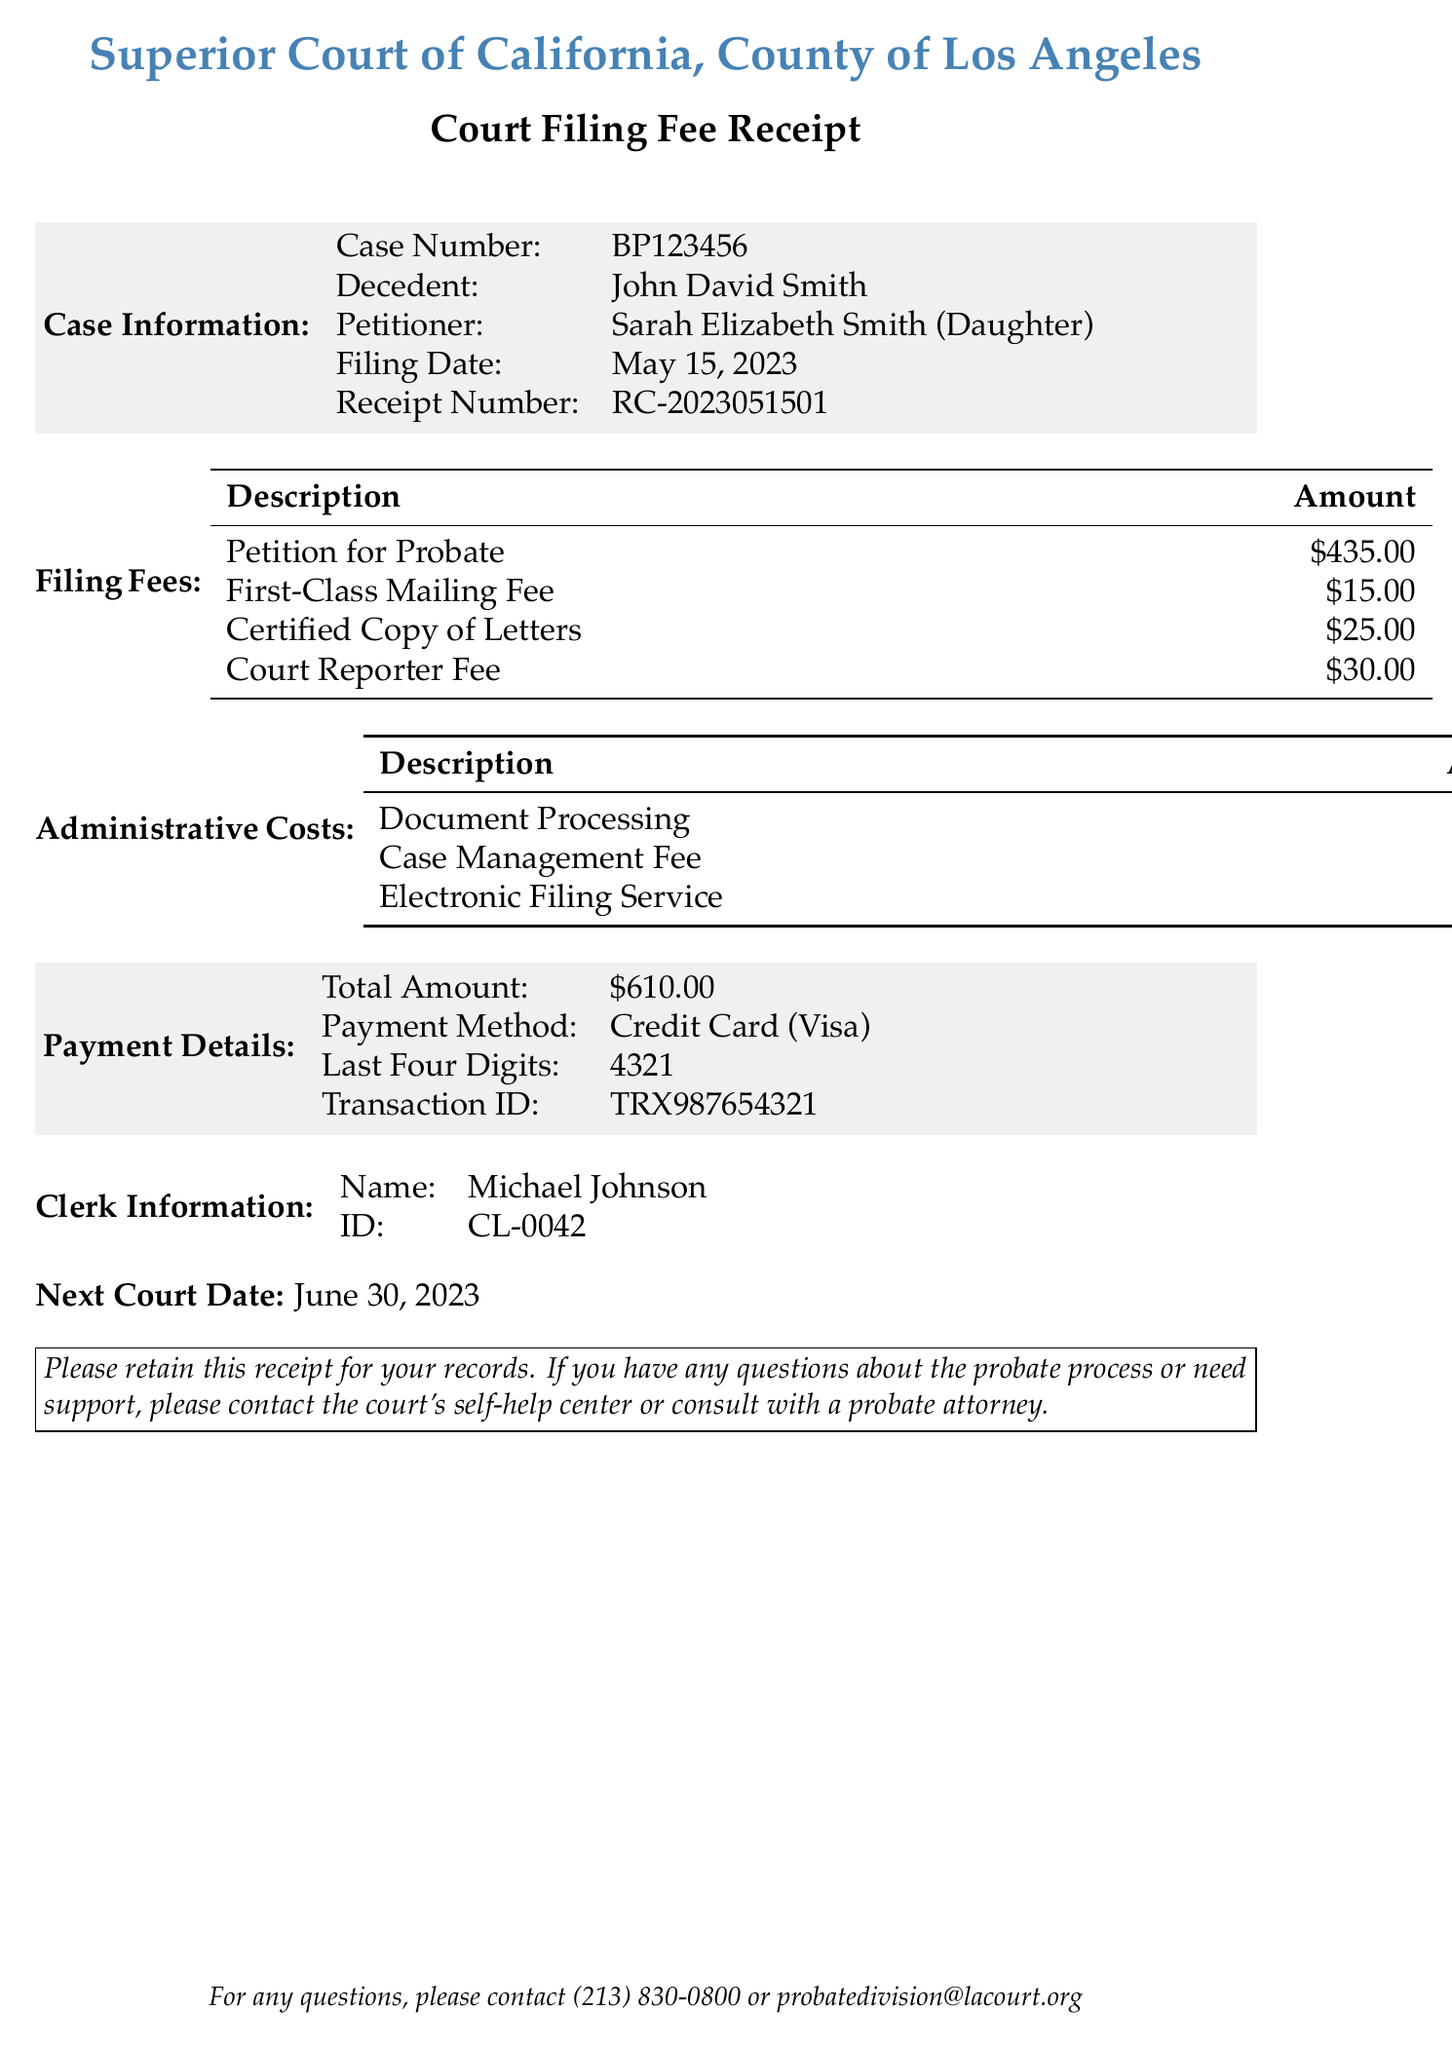What is the name of the decedent? The decedent's name is listed in the document as John David Smith.
Answer: John David Smith What is the total amount of filing fees? The total of the listed filing fees is $435.00 + $15.00 + $25.00 + $30.00 = $505.00.
Answer: $505.00 Who is the petitioner? The document states the petitioner's name as Sarah Elizabeth Smith.
Answer: Sarah Elizabeth Smith What is the case number? The case number is specifically provided in the document as BP123456.
Answer: BP123456 What is the filing date? The filing date appears in the document as May 15, 2023.
Answer: May 15, 2023 What is the amount for the Document Processing fee? The Document Processing fee amount is clearly mentioned in the administrative costs as $50.00.
Answer: $50.00 What is the payment method used? The payment method is described in the receipt as Credit Card.
Answer: Credit Card Who is the clerk of the court? The clerk's name is provided in the document as Michael Johnson.
Answer: Michael Johnson What is the next court date mentioned? The document specifies the next court date as June 30, 2023.
Answer: June 30, 2023 